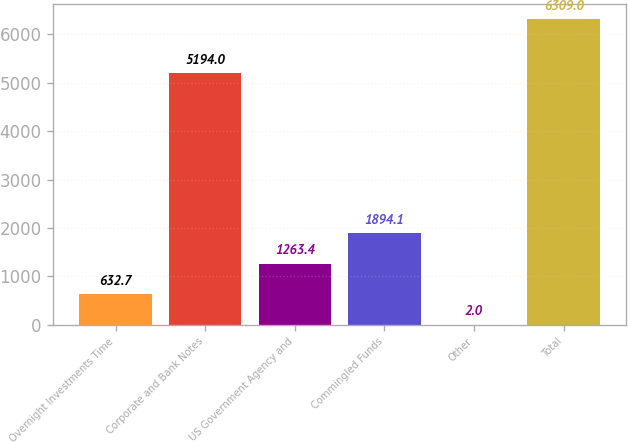<chart> <loc_0><loc_0><loc_500><loc_500><bar_chart><fcel>Overnight Investments Time<fcel>Corporate and Bank Notes<fcel>US Government Agency and<fcel>Commingled Funds<fcel>Other<fcel>Total<nl><fcel>632.7<fcel>5194<fcel>1263.4<fcel>1894.1<fcel>2<fcel>6309<nl></chart> 